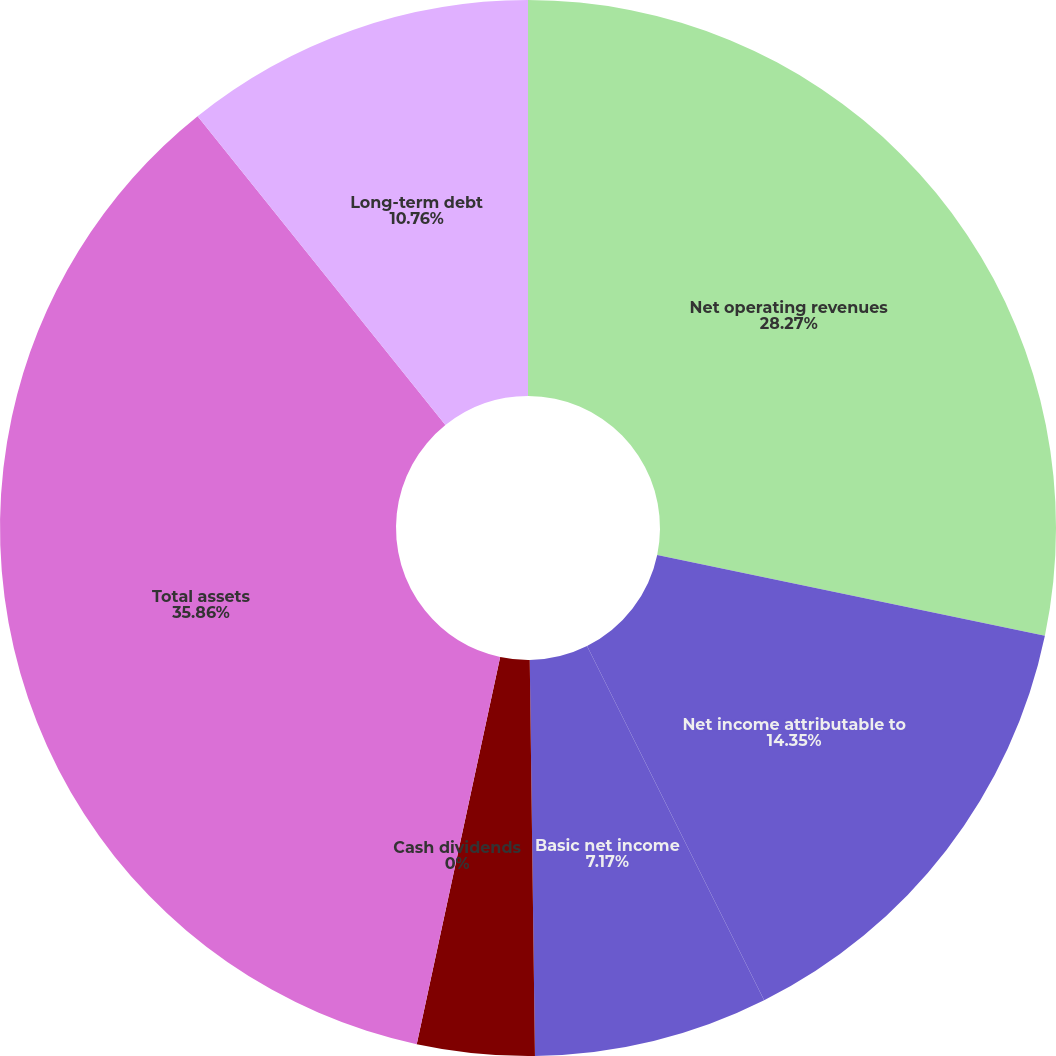<chart> <loc_0><loc_0><loc_500><loc_500><pie_chart><fcel>Net operating revenues<fcel>Net income attributable to<fcel>Basic net income<fcel>Diluted net income<fcel>Cash dividends<fcel>Total assets<fcel>Long-term debt<nl><fcel>28.27%<fcel>14.35%<fcel>7.17%<fcel>3.59%<fcel>0.0%<fcel>35.86%<fcel>10.76%<nl></chart> 